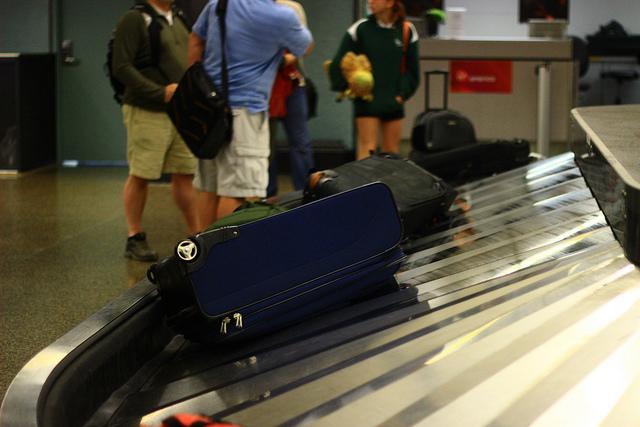How many people are standing at the luggage carrier?
Quick response, please. 4. Is the suitcase upside down?
Short answer required. Yes. What color is the luggage above the conveyor?
Answer briefly. Blue. Is there a table in the image?
Write a very short answer. Yes. What color is both men's shirt?
Be succinct. Blue and green. How many people in the background are wearing pants?
Quick response, please. 1. What color is the man's backpack?
Keep it brief. Black. Where would you likely see this image?
Quick response, please. Airport. 